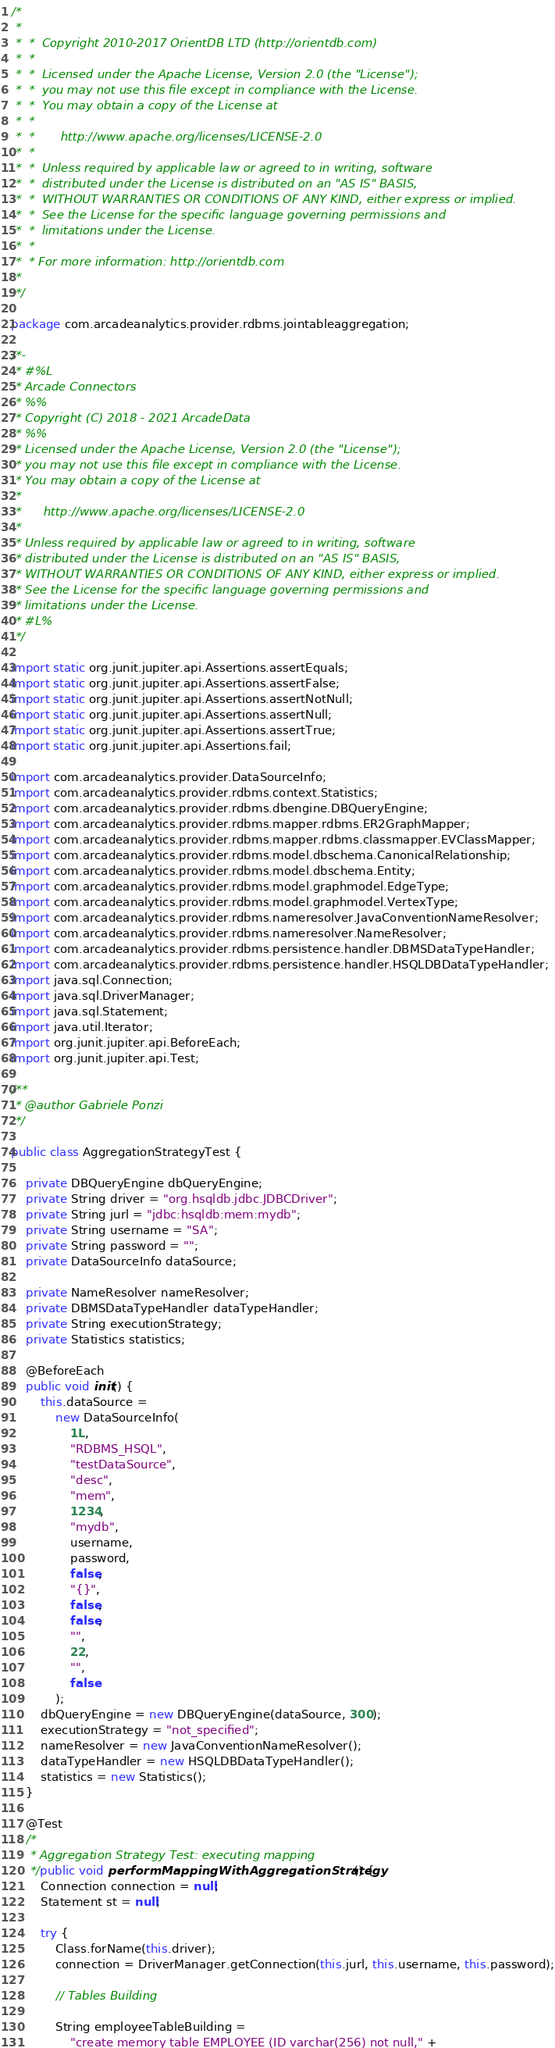Convert code to text. <code><loc_0><loc_0><loc_500><loc_500><_Java_>/*
 *
 *  *  Copyright 2010-2017 OrientDB LTD (http://orientdb.com)
 *  *
 *  *  Licensed under the Apache License, Version 2.0 (the "License");
 *  *  you may not use this file except in compliance with the License.
 *  *  You may obtain a copy of the License at
 *  *
 *  *       http://www.apache.org/licenses/LICENSE-2.0
 *  *
 *  *  Unless required by applicable law or agreed to in writing, software
 *  *  distributed under the License is distributed on an "AS IS" BASIS,
 *  *  WITHOUT WARRANTIES OR CONDITIONS OF ANY KIND, either express or implied.
 *  *  See the License for the specific language governing permissions and
 *  *  limitations under the License.
 *  *
 *  * For more information: http://orientdb.com
 *
 */

package com.arcadeanalytics.provider.rdbms.jointableaggregation;

/*-
 * #%L
 * Arcade Connectors
 * %%
 * Copyright (C) 2018 - 2021 ArcadeData
 * %%
 * Licensed under the Apache License, Version 2.0 (the "License");
 * you may not use this file except in compliance with the License.
 * You may obtain a copy of the License at
 *
 *      http://www.apache.org/licenses/LICENSE-2.0
 *
 * Unless required by applicable law or agreed to in writing, software
 * distributed under the License is distributed on an "AS IS" BASIS,
 * WITHOUT WARRANTIES OR CONDITIONS OF ANY KIND, either express or implied.
 * See the License for the specific language governing permissions and
 * limitations under the License.
 * #L%
 */

import static org.junit.jupiter.api.Assertions.assertEquals;
import static org.junit.jupiter.api.Assertions.assertFalse;
import static org.junit.jupiter.api.Assertions.assertNotNull;
import static org.junit.jupiter.api.Assertions.assertNull;
import static org.junit.jupiter.api.Assertions.assertTrue;
import static org.junit.jupiter.api.Assertions.fail;

import com.arcadeanalytics.provider.DataSourceInfo;
import com.arcadeanalytics.provider.rdbms.context.Statistics;
import com.arcadeanalytics.provider.rdbms.dbengine.DBQueryEngine;
import com.arcadeanalytics.provider.rdbms.mapper.rdbms.ER2GraphMapper;
import com.arcadeanalytics.provider.rdbms.mapper.rdbms.classmapper.EVClassMapper;
import com.arcadeanalytics.provider.rdbms.model.dbschema.CanonicalRelationship;
import com.arcadeanalytics.provider.rdbms.model.dbschema.Entity;
import com.arcadeanalytics.provider.rdbms.model.graphmodel.EdgeType;
import com.arcadeanalytics.provider.rdbms.model.graphmodel.VertexType;
import com.arcadeanalytics.provider.rdbms.nameresolver.JavaConventionNameResolver;
import com.arcadeanalytics.provider.rdbms.nameresolver.NameResolver;
import com.arcadeanalytics.provider.rdbms.persistence.handler.DBMSDataTypeHandler;
import com.arcadeanalytics.provider.rdbms.persistence.handler.HSQLDBDataTypeHandler;
import java.sql.Connection;
import java.sql.DriverManager;
import java.sql.Statement;
import java.util.Iterator;
import org.junit.jupiter.api.BeforeEach;
import org.junit.jupiter.api.Test;

/**
 * @author Gabriele Ponzi
 */

public class AggregationStrategyTest {

    private DBQueryEngine dbQueryEngine;
    private String driver = "org.hsqldb.jdbc.JDBCDriver";
    private String jurl = "jdbc:hsqldb:mem:mydb";
    private String username = "SA";
    private String password = "";
    private DataSourceInfo dataSource;

    private NameResolver nameResolver;
    private DBMSDataTypeHandler dataTypeHandler;
    private String executionStrategy;
    private Statistics statistics;

    @BeforeEach
    public void init() {
        this.dataSource =
            new DataSourceInfo(
                1L,
                "RDBMS_HSQL",
                "testDataSource",
                "desc",
                "mem",
                1234,
                "mydb",
                username,
                password,
                false,
                "{}",
                false,
                false,
                "",
                22,
                "",
                false
            );
        dbQueryEngine = new DBQueryEngine(dataSource, 300);
        executionStrategy = "not_specified";
        nameResolver = new JavaConventionNameResolver();
        dataTypeHandler = new HSQLDBDataTypeHandler();
        statistics = new Statistics();
    }

    @Test
    /*
     * Aggregation Strategy Test: executing mapping
     */public void performMappingWithAggregationStrategy() {
        Connection connection = null;
        Statement st = null;

        try {
            Class.forName(this.driver);
            connection = DriverManager.getConnection(this.jurl, this.username, this.password);

            // Tables Building

            String employeeTableBuilding =
                "create memory table EMPLOYEE (ID varchar(256) not null," +</code> 